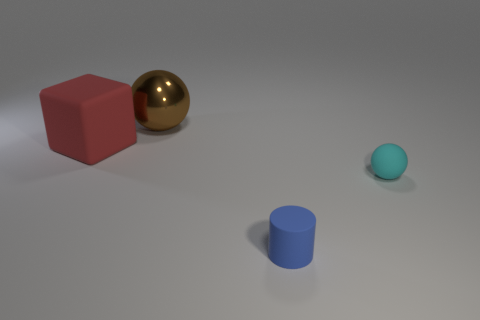Add 2 big shiny balls. How many objects exist? 6 Subtract all brown balls. How many balls are left? 1 Subtract all cylinders. How many objects are left? 3 Subtract all big green rubber objects. Subtract all tiny blue rubber things. How many objects are left? 3 Add 1 metallic things. How many metallic things are left? 2 Add 1 tiny cyan balls. How many tiny cyan balls exist? 2 Subtract 1 cyan spheres. How many objects are left? 3 Subtract 1 blocks. How many blocks are left? 0 Subtract all gray cylinders. Subtract all cyan spheres. How many cylinders are left? 1 